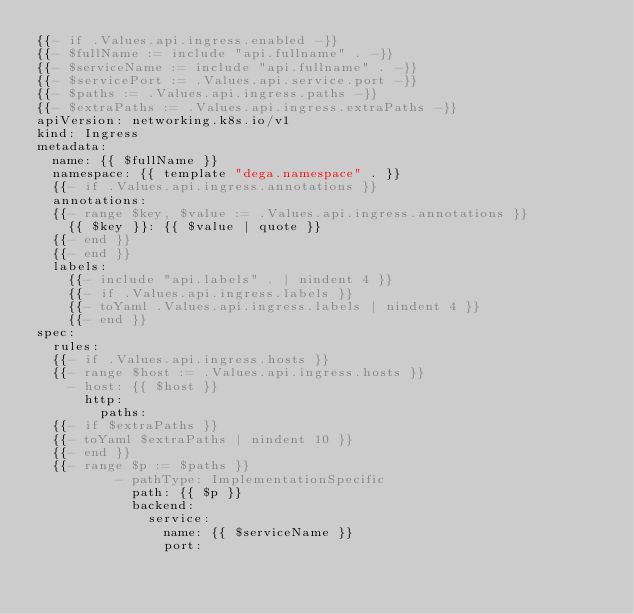Convert code to text. <code><loc_0><loc_0><loc_500><loc_500><_YAML_>{{- if .Values.api.ingress.enabled -}}
{{- $fullName := include "api.fullname" . -}}
{{- $serviceName := include "api.fullname" . -}}
{{- $servicePort := .Values.api.service.port -}}
{{- $paths := .Values.api.ingress.paths -}}
{{- $extraPaths := .Values.api.ingress.extraPaths -}}
apiVersion: networking.k8s.io/v1
kind: Ingress
metadata:
  name: {{ $fullName }}
  namespace: {{ template "dega.namespace" . }}  
  {{- if .Values.api.ingress.annotations }}
  annotations:
  {{- range $key, $value := .Values.api.ingress.annotations }}
    {{ $key }}: {{ $value | quote }}
  {{- end }}
  {{- end }}
  labels:
    {{- include "api.labels" . | nindent 4 }}
    {{- if .Values.api.ingress.labels }}
    {{- toYaml .Values.api.ingress.labels | nindent 4 }}
    {{- end }}
spec:
  rules:
  {{- if .Values.api.ingress.hosts }}
  {{- range $host := .Values.api.ingress.hosts }}
    - host: {{ $host }}
      http:
        paths:
  {{- if $extraPaths }}
  {{- toYaml $extraPaths | nindent 10 }}
  {{- end }}
  {{- range $p := $paths }}
          - pathType: ImplementationSpecific
            path: {{ $p }}
            backend:
              service:
                name: {{ $serviceName }}
                port: </code> 